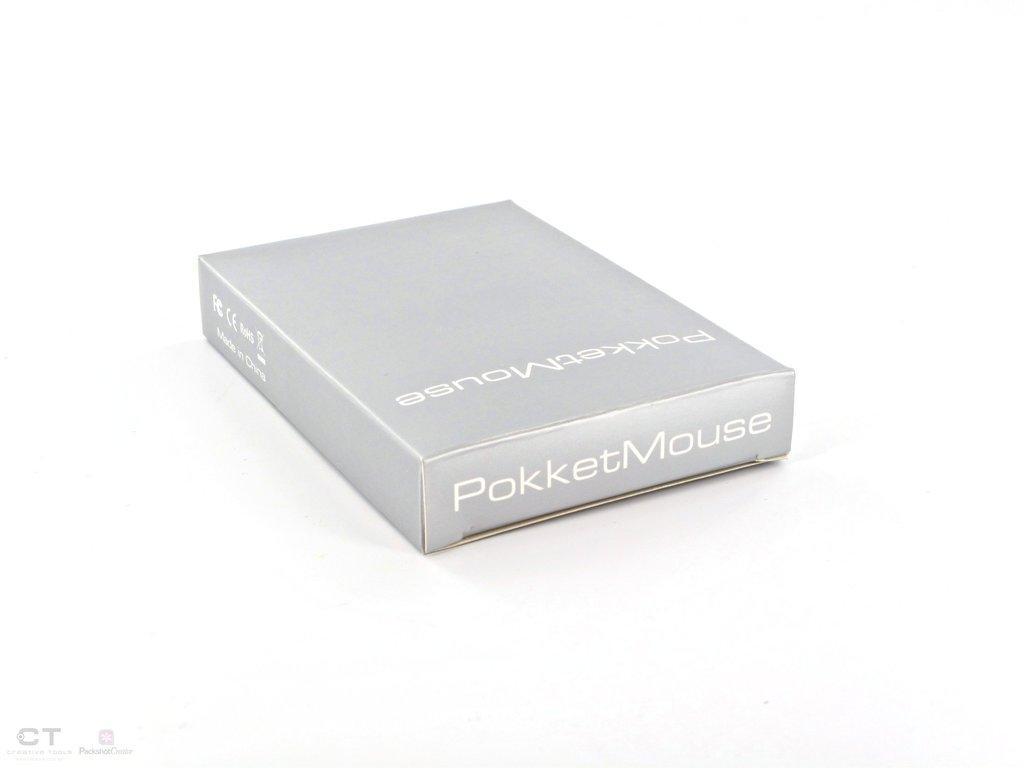Describe this image in one or two sentences. In this image I can see the box which is in ash color. And I can see the name pocket mouse is written on it. It is on the white color surface. 